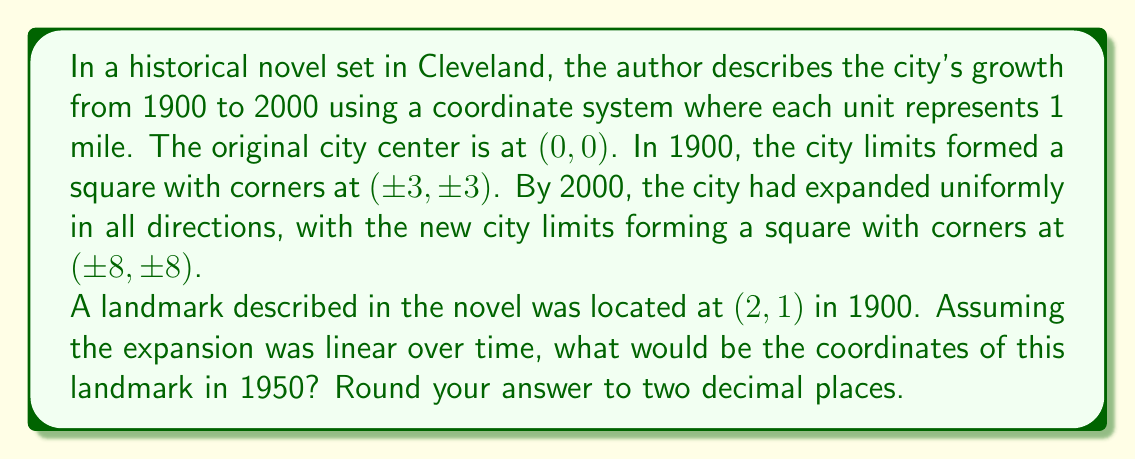Give your solution to this math problem. To solve this problem, we need to understand how the coordinate system has changed over time:

1. In 1900, the city limits were at (±3, ±3)
2. In 2000, the city limits expanded to (±8, ±8)
3. We need to find the location in 1950, which is halfway between these two points in time

Let's approach this step-by-step:

1. Calculate the total expansion from 1900 to 2000:
   - X-axis expansion: 8 - 3 = 5 units
   - Y-axis expansion: 8 - 3 = 5 units

2. Since the expansion is uniform and linear, we can calculate the expansion factor for 50 years (half of the total time):
   $$ \text{Expansion factor} = \frac{1}{2} \cdot \frac{8}{3} = \frac{4}{3} $$

3. Now, we can apply this expansion factor to the original coordinates (2, 1):
   $$ x_{1950} = 2 \cdot \frac{4}{3} = \frac{8}{3} = 2.67 $$
   $$ y_{1950} = 1 \cdot \frac{4}{3} = \frac{4}{3} = 1.33 $$

4. Rounding to two decimal places:
   $x_{1950} \approx 2.67$
   $y_{1950} \approx 1.33$

Therefore, the coordinates of the landmark in 1950 would be approximately (2.67, 1.33).
Answer: (2.67, 1.33) 